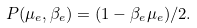Convert formula to latex. <formula><loc_0><loc_0><loc_500><loc_500>P ( \mu _ { e } , \beta _ { e } ) = ( 1 - \beta _ { e } \mu _ { e } ) / 2 .</formula> 